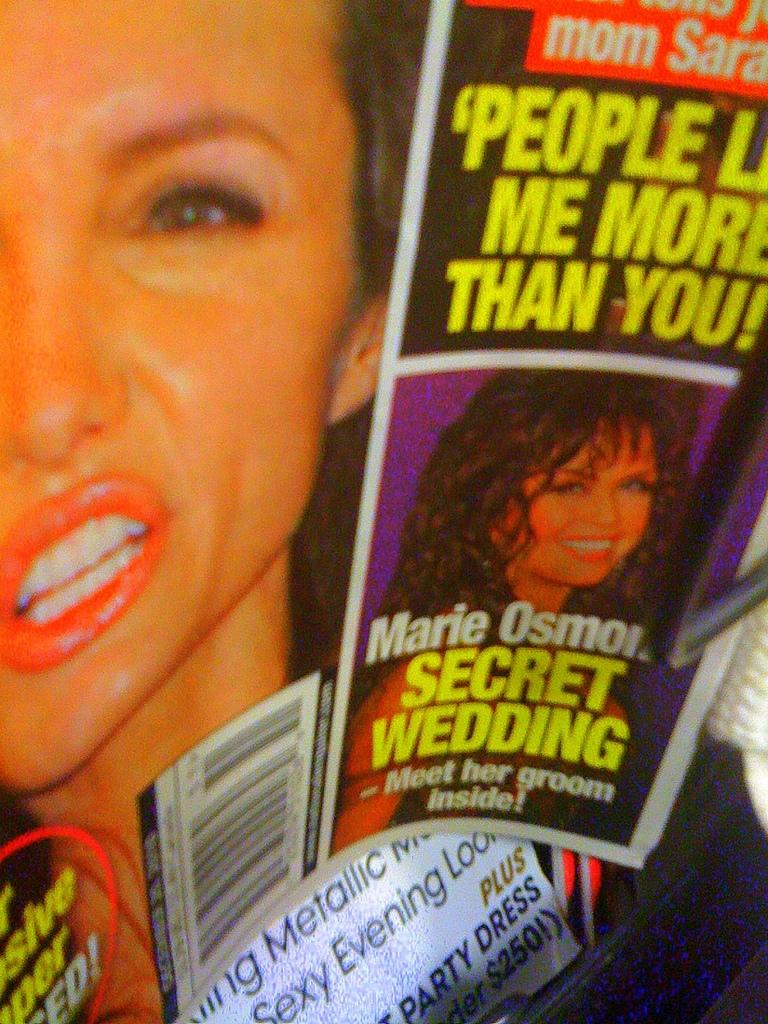<image>
Relay a brief, clear account of the picture shown. A celebrity gossip magazine with an article about Marie Osmon. 